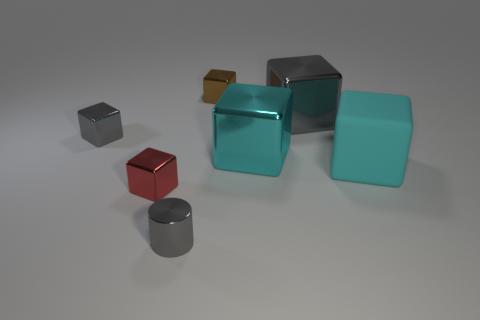Does the gray cube that is to the left of the metallic cylinder have the same material as the small red cube?
Your answer should be compact. Yes. What is the color of the shiny cylinder that is the same size as the red shiny object?
Keep it short and to the point. Gray. Are there any cyan metallic objects of the same shape as the brown object?
Ensure brevity in your answer.  Yes. There is a large shiny block behind the small gray thing behind the small gray object in front of the small gray shiny cube; what color is it?
Offer a terse response. Gray. What number of metallic objects are small cubes or large yellow cylinders?
Provide a succinct answer. 3. Are there more small metallic cylinders right of the tiny brown metallic block than big cyan matte cubes in front of the cyan matte object?
Make the answer very short. No. What number of other objects are there of the same size as the red metallic thing?
Provide a short and direct response. 3. There is a cyan thing behind the rubber block that is in front of the brown metallic block; what is its size?
Keep it short and to the point. Large. How many tiny things are either cyan cubes or blocks?
Make the answer very short. 3. How big is the object behind the large cube behind the cyan cube behind the cyan matte thing?
Provide a short and direct response. Small. 